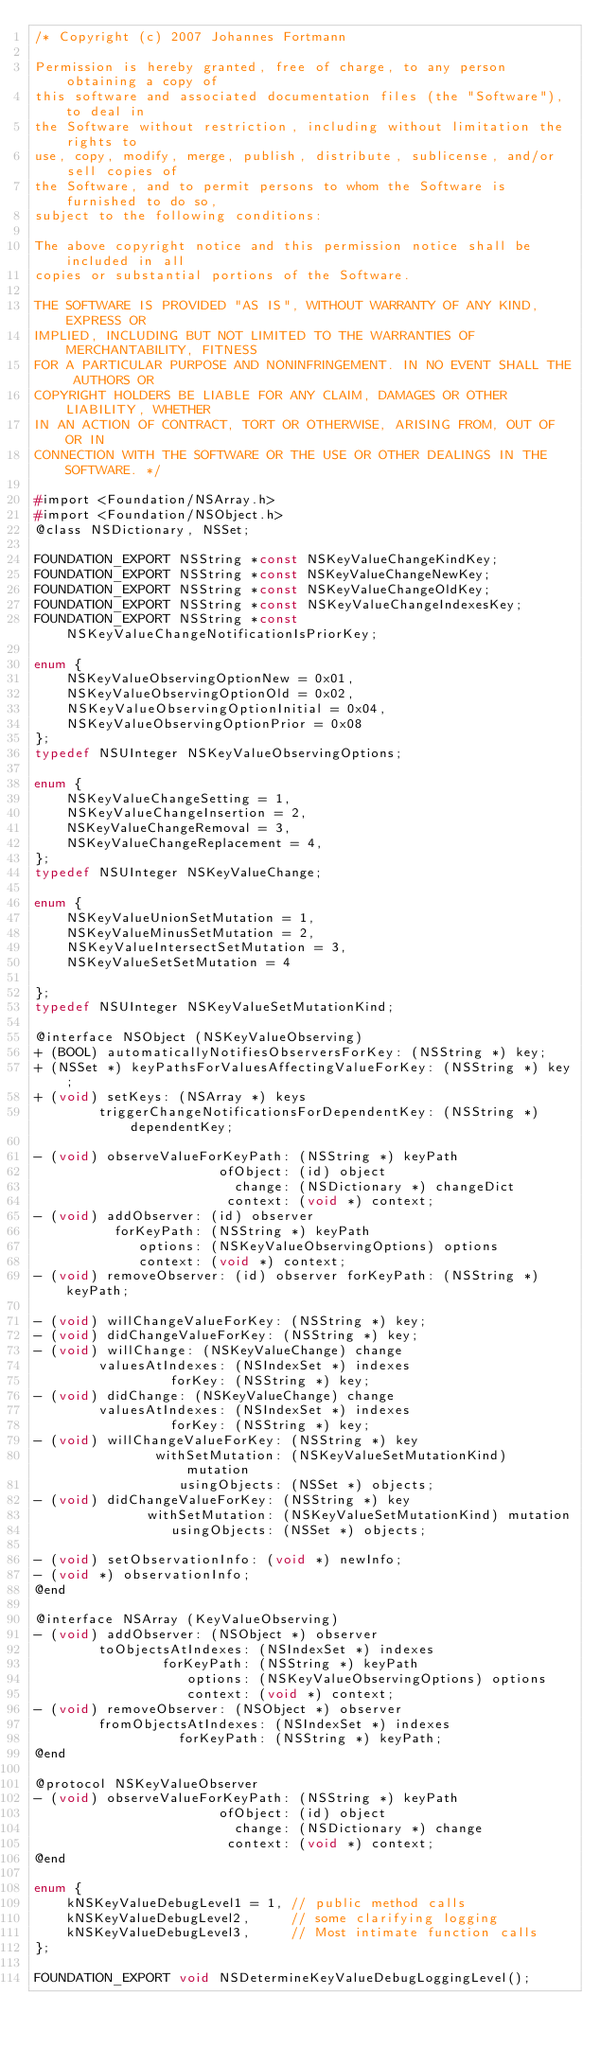Convert code to text. <code><loc_0><loc_0><loc_500><loc_500><_C_>/* Copyright (c) 2007 Johannes Fortmann

Permission is hereby granted, free of charge, to any person obtaining a copy of
this software and associated documentation files (the "Software"), to deal in
the Software without restriction, including without limitation the rights to
use, copy, modify, merge, publish, distribute, sublicense, and/or sell copies of
the Software, and to permit persons to whom the Software is furnished to do so,
subject to the following conditions:

The above copyright notice and this permission notice shall be included in all
copies or substantial portions of the Software.

THE SOFTWARE IS PROVIDED "AS IS", WITHOUT WARRANTY OF ANY KIND, EXPRESS OR
IMPLIED, INCLUDING BUT NOT LIMITED TO THE WARRANTIES OF MERCHANTABILITY, FITNESS
FOR A PARTICULAR PURPOSE AND NONINFRINGEMENT. IN NO EVENT SHALL THE AUTHORS OR
COPYRIGHT HOLDERS BE LIABLE FOR ANY CLAIM, DAMAGES OR OTHER LIABILITY, WHETHER
IN AN ACTION OF CONTRACT, TORT OR OTHERWISE, ARISING FROM, OUT OF OR IN
CONNECTION WITH THE SOFTWARE OR THE USE OR OTHER DEALINGS IN THE SOFTWARE. */

#import <Foundation/NSArray.h>
#import <Foundation/NSObject.h>
@class NSDictionary, NSSet;

FOUNDATION_EXPORT NSString *const NSKeyValueChangeKindKey;
FOUNDATION_EXPORT NSString *const NSKeyValueChangeNewKey;
FOUNDATION_EXPORT NSString *const NSKeyValueChangeOldKey;
FOUNDATION_EXPORT NSString *const NSKeyValueChangeIndexesKey;
FOUNDATION_EXPORT NSString *const NSKeyValueChangeNotificationIsPriorKey;

enum {
    NSKeyValueObservingOptionNew = 0x01,
    NSKeyValueObservingOptionOld = 0x02,
    NSKeyValueObservingOptionInitial = 0x04,
    NSKeyValueObservingOptionPrior = 0x08
};
typedef NSUInteger NSKeyValueObservingOptions;

enum {
    NSKeyValueChangeSetting = 1,
    NSKeyValueChangeInsertion = 2,
    NSKeyValueChangeRemoval = 3,
    NSKeyValueChangeReplacement = 4,
};
typedef NSUInteger NSKeyValueChange;

enum {
    NSKeyValueUnionSetMutation = 1,
    NSKeyValueMinusSetMutation = 2,
    NSKeyValueIntersectSetMutation = 3,
    NSKeyValueSetSetMutation = 4

};
typedef NSUInteger NSKeyValueSetMutationKind;

@interface NSObject (NSKeyValueObserving)
+ (BOOL) automaticallyNotifiesObserversForKey: (NSString *) key;
+ (NSSet *) keyPathsForValuesAffectingValueForKey: (NSString *) key;
+ (void) setKeys: (NSArray *) keys
        triggerChangeNotificationsForDependentKey: (NSString *) dependentKey;

- (void) observeValueForKeyPath: (NSString *) keyPath
                       ofObject: (id) object
                         change: (NSDictionary *) changeDict
                        context: (void *) context;
- (void) addObserver: (id) observer
          forKeyPath: (NSString *) keyPath
             options: (NSKeyValueObservingOptions) options
             context: (void *) context;
- (void) removeObserver: (id) observer forKeyPath: (NSString *) keyPath;

- (void) willChangeValueForKey: (NSString *) key;
- (void) didChangeValueForKey: (NSString *) key;
- (void) willChange: (NSKeyValueChange) change
        valuesAtIndexes: (NSIndexSet *) indexes
                 forKey: (NSString *) key;
- (void) didChange: (NSKeyValueChange) change
        valuesAtIndexes: (NSIndexSet *) indexes
                 forKey: (NSString *) key;
- (void) willChangeValueForKey: (NSString *) key
               withSetMutation: (NSKeyValueSetMutationKind) mutation
                  usingObjects: (NSSet *) objects;
- (void) didChangeValueForKey: (NSString *) key
              withSetMutation: (NSKeyValueSetMutationKind) mutation
                 usingObjects: (NSSet *) objects;

- (void) setObservationInfo: (void *) newInfo;
- (void *) observationInfo;
@end

@interface NSArray (KeyValueObserving)
- (void) addObserver: (NSObject *) observer
        toObjectsAtIndexes: (NSIndexSet *) indexes
                forKeyPath: (NSString *) keyPath
                   options: (NSKeyValueObservingOptions) options
                   context: (void *) context;
- (void) removeObserver: (NSObject *) observer
        fromObjectsAtIndexes: (NSIndexSet *) indexes
                  forKeyPath: (NSString *) keyPath;
@end

@protocol NSKeyValueObserver
- (void) observeValueForKeyPath: (NSString *) keyPath
                       ofObject: (id) object
                         change: (NSDictionary *) change
                        context: (void *) context;
@end

enum {
    kNSKeyValueDebugLevel1 = 1, // public method calls
    kNSKeyValueDebugLevel2,     // some clarifying logging
    kNSKeyValueDebugLevel3,     // Most intimate function calls
};

FOUNDATION_EXPORT void NSDetermineKeyValueDebugLoggingLevel();
</code> 